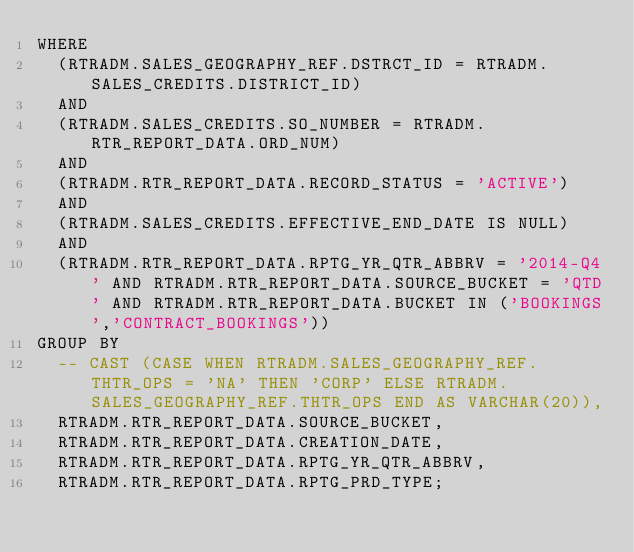Convert code to text. <code><loc_0><loc_0><loc_500><loc_500><_SQL_>WHERE 
  (RTRADM.SALES_GEOGRAPHY_REF.DSTRCT_ID = RTRADM.SALES_CREDITS.DISTRICT_ID) 
  AND 
  (RTRADM.SALES_CREDITS.SO_NUMBER = RTRADM.RTR_REPORT_DATA.ORD_NUM) 
  AND 
  (RTRADM.RTR_REPORT_DATA.RECORD_STATUS = 'ACTIVE') 
  AND 
  (RTRADM.SALES_CREDITS.EFFECTIVE_END_DATE IS NULL) 
  AND 
  (RTRADM.RTR_REPORT_DATA.RPTG_YR_QTR_ABBRV = '2014-Q4' AND RTRADM.RTR_REPORT_DATA.SOURCE_BUCKET = 'QTD' AND RTRADM.RTR_REPORT_DATA.BUCKET IN ('BOOKINGS','CONTRACT_BOOKINGS')) 
GROUP BY 
  -- CAST (CASE WHEN RTRADM.SALES_GEOGRAPHY_REF.THTR_OPS = 'NA' THEN 'CORP' ELSE RTRADM.SALES_GEOGRAPHY_REF.THTR_OPS END AS VARCHAR(20)), 
  RTRADM.RTR_REPORT_DATA.SOURCE_BUCKET, 
  RTRADM.RTR_REPORT_DATA.CREATION_DATE, 
  RTRADM.RTR_REPORT_DATA.RPTG_YR_QTR_ABBRV, 
  RTRADM.RTR_REPORT_DATA.RPTG_PRD_TYPE;
</code> 